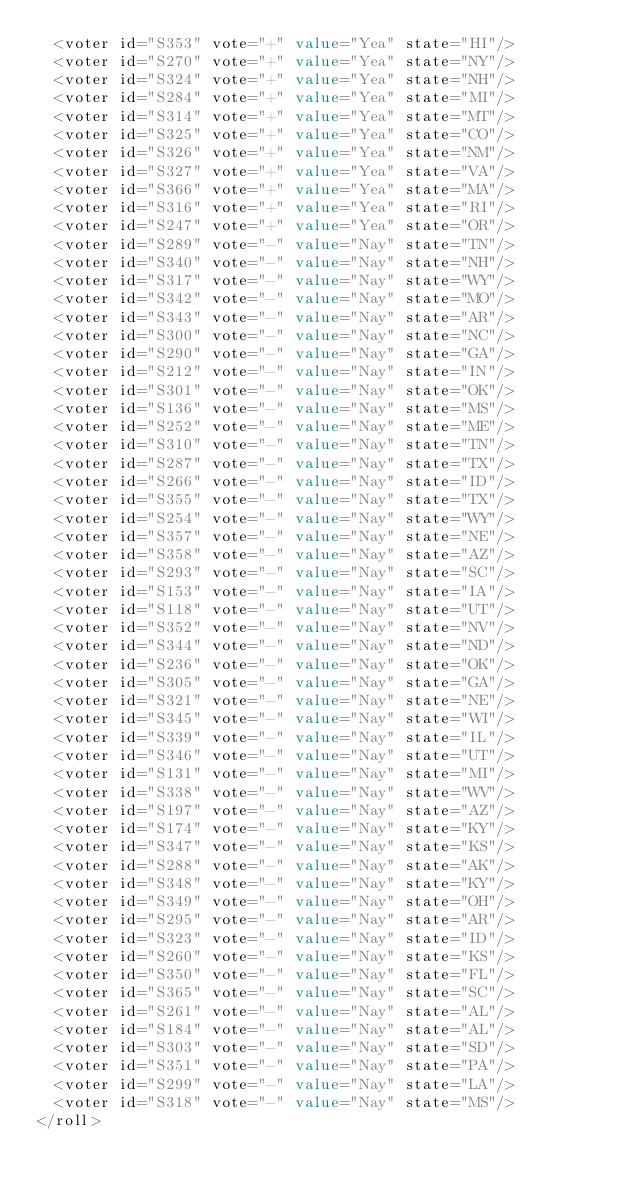Convert code to text. <code><loc_0><loc_0><loc_500><loc_500><_XML_>  <voter id="S353" vote="+" value="Yea" state="HI"/>
  <voter id="S270" vote="+" value="Yea" state="NY"/>
  <voter id="S324" vote="+" value="Yea" state="NH"/>
  <voter id="S284" vote="+" value="Yea" state="MI"/>
  <voter id="S314" vote="+" value="Yea" state="MT"/>
  <voter id="S325" vote="+" value="Yea" state="CO"/>
  <voter id="S326" vote="+" value="Yea" state="NM"/>
  <voter id="S327" vote="+" value="Yea" state="VA"/>
  <voter id="S366" vote="+" value="Yea" state="MA"/>
  <voter id="S316" vote="+" value="Yea" state="RI"/>
  <voter id="S247" vote="+" value="Yea" state="OR"/>
  <voter id="S289" vote="-" value="Nay" state="TN"/>
  <voter id="S340" vote="-" value="Nay" state="NH"/>
  <voter id="S317" vote="-" value="Nay" state="WY"/>
  <voter id="S342" vote="-" value="Nay" state="MO"/>
  <voter id="S343" vote="-" value="Nay" state="AR"/>
  <voter id="S300" vote="-" value="Nay" state="NC"/>
  <voter id="S290" vote="-" value="Nay" state="GA"/>
  <voter id="S212" vote="-" value="Nay" state="IN"/>
  <voter id="S301" vote="-" value="Nay" state="OK"/>
  <voter id="S136" vote="-" value="Nay" state="MS"/>
  <voter id="S252" vote="-" value="Nay" state="ME"/>
  <voter id="S310" vote="-" value="Nay" state="TN"/>
  <voter id="S287" vote="-" value="Nay" state="TX"/>
  <voter id="S266" vote="-" value="Nay" state="ID"/>
  <voter id="S355" vote="-" value="Nay" state="TX"/>
  <voter id="S254" vote="-" value="Nay" state="WY"/>
  <voter id="S357" vote="-" value="Nay" state="NE"/>
  <voter id="S358" vote="-" value="Nay" state="AZ"/>
  <voter id="S293" vote="-" value="Nay" state="SC"/>
  <voter id="S153" vote="-" value="Nay" state="IA"/>
  <voter id="S118" vote="-" value="Nay" state="UT"/>
  <voter id="S352" vote="-" value="Nay" state="NV"/>
  <voter id="S344" vote="-" value="Nay" state="ND"/>
  <voter id="S236" vote="-" value="Nay" state="OK"/>
  <voter id="S305" vote="-" value="Nay" state="GA"/>
  <voter id="S321" vote="-" value="Nay" state="NE"/>
  <voter id="S345" vote="-" value="Nay" state="WI"/>
  <voter id="S339" vote="-" value="Nay" state="IL"/>
  <voter id="S346" vote="-" value="Nay" state="UT"/>
  <voter id="S131" vote="-" value="Nay" state="MI"/>
  <voter id="S338" vote="-" value="Nay" state="WV"/>
  <voter id="S197" vote="-" value="Nay" state="AZ"/>
  <voter id="S174" vote="-" value="Nay" state="KY"/>
  <voter id="S347" vote="-" value="Nay" state="KS"/>
  <voter id="S288" vote="-" value="Nay" state="AK"/>
  <voter id="S348" vote="-" value="Nay" state="KY"/>
  <voter id="S349" vote="-" value="Nay" state="OH"/>
  <voter id="S295" vote="-" value="Nay" state="AR"/>
  <voter id="S323" vote="-" value="Nay" state="ID"/>
  <voter id="S260" vote="-" value="Nay" state="KS"/>
  <voter id="S350" vote="-" value="Nay" state="FL"/>
  <voter id="S365" vote="-" value="Nay" state="SC"/>
  <voter id="S261" vote="-" value="Nay" state="AL"/>
  <voter id="S184" vote="-" value="Nay" state="AL"/>
  <voter id="S303" vote="-" value="Nay" state="SD"/>
  <voter id="S351" vote="-" value="Nay" state="PA"/>
  <voter id="S299" vote="-" value="Nay" state="LA"/>
  <voter id="S318" vote="-" value="Nay" state="MS"/>
</roll>
</code> 